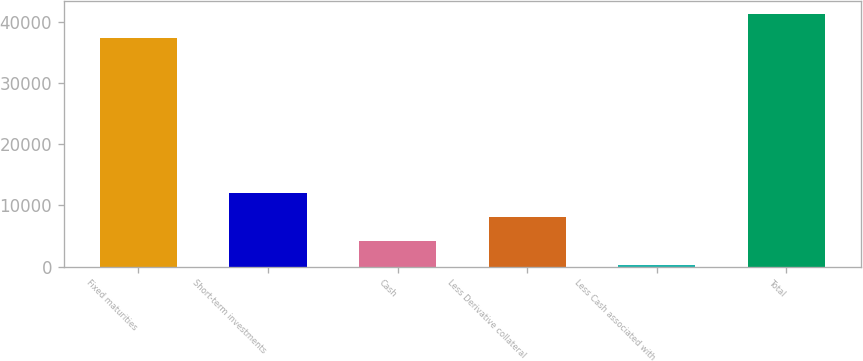Convert chart to OTSL. <chart><loc_0><loc_0><loc_500><loc_500><bar_chart><fcel>Fixed maturities<fcel>Short-term investments<fcel>Cash<fcel>Less Derivative collateral<fcel>Less Cash associated with<fcel>Total<nl><fcel>37432<fcel>12001.1<fcel>4187.7<fcel>8094.4<fcel>281<fcel>41338.7<nl></chart> 